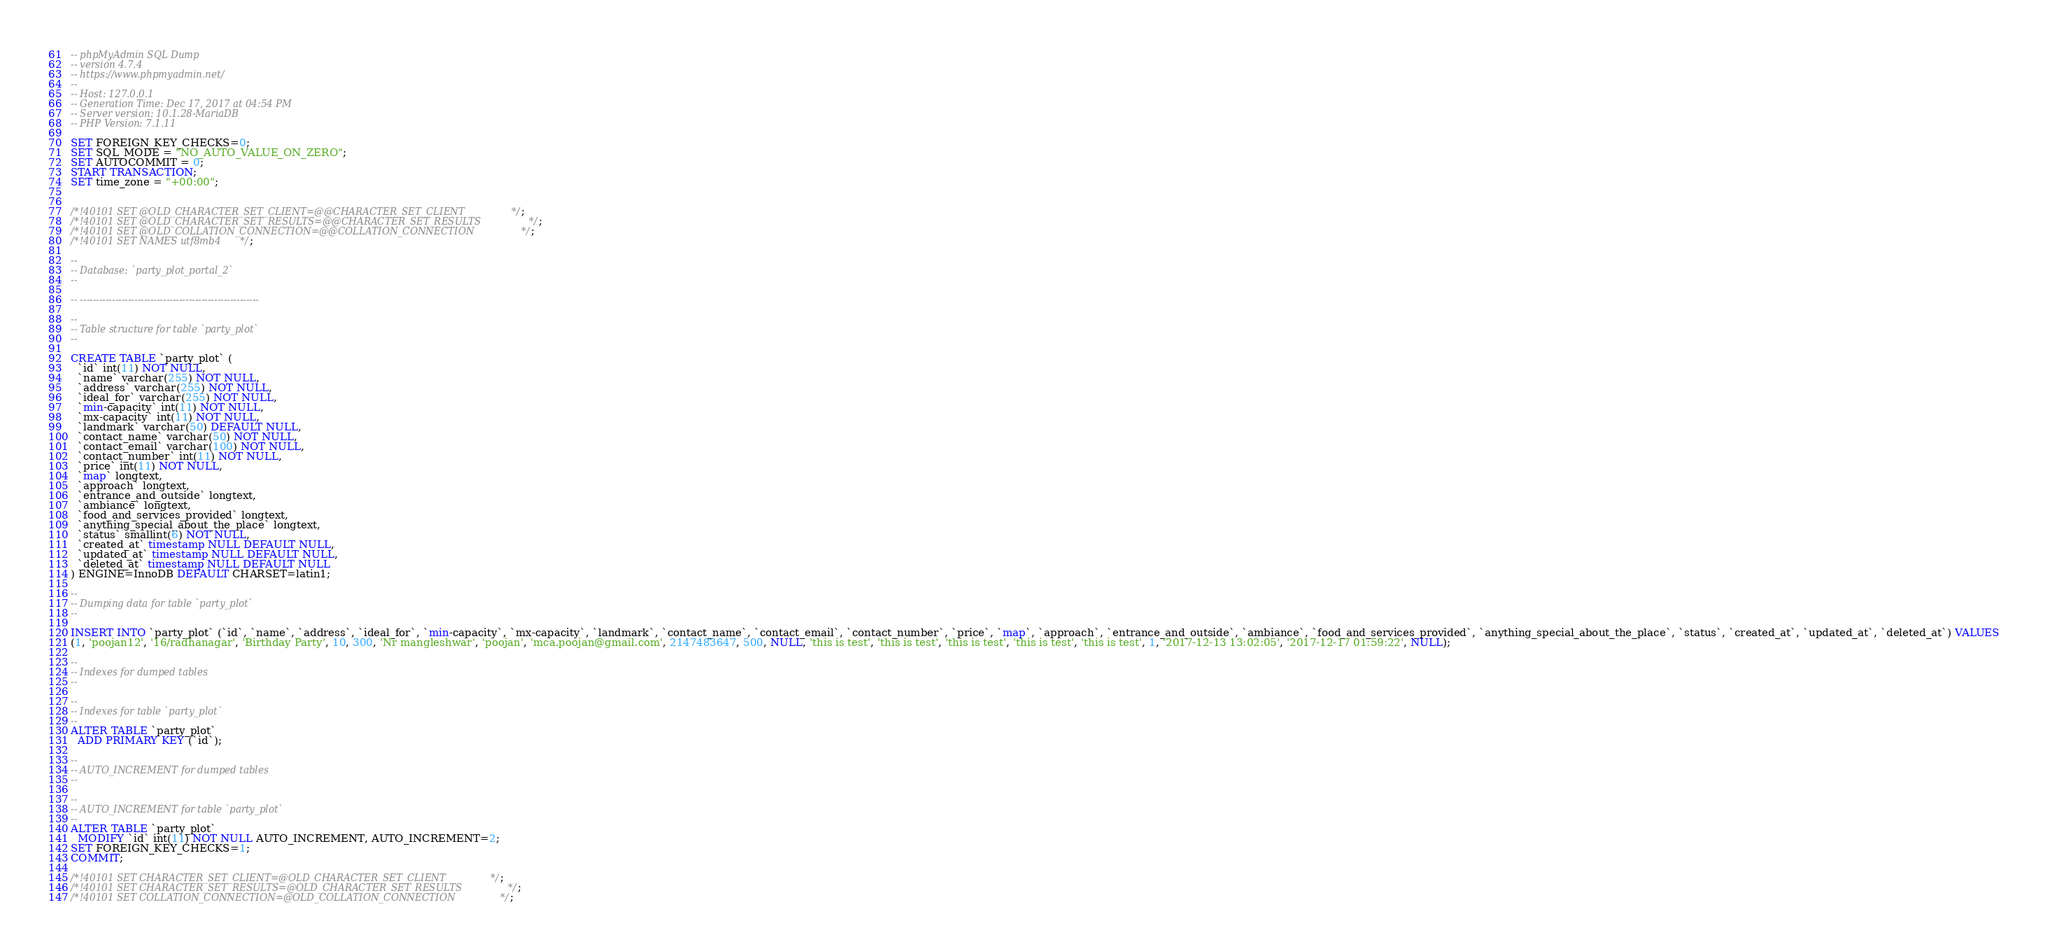<code> <loc_0><loc_0><loc_500><loc_500><_SQL_>-- phpMyAdmin SQL Dump
-- version 4.7.4
-- https://www.phpmyadmin.net/
--
-- Host: 127.0.0.1
-- Generation Time: Dec 17, 2017 at 04:54 PM
-- Server version: 10.1.28-MariaDB
-- PHP Version: 7.1.11

SET FOREIGN_KEY_CHECKS=0;
SET SQL_MODE = "NO_AUTO_VALUE_ON_ZERO";
SET AUTOCOMMIT = 0;
START TRANSACTION;
SET time_zone = "+00:00";


/*!40101 SET @OLD_CHARACTER_SET_CLIENT=@@CHARACTER_SET_CLIENT */;
/*!40101 SET @OLD_CHARACTER_SET_RESULTS=@@CHARACTER_SET_RESULTS */;
/*!40101 SET @OLD_COLLATION_CONNECTION=@@COLLATION_CONNECTION */;
/*!40101 SET NAMES utf8mb4 */;

--
-- Database: `party_plot_portal_2`
--

-- --------------------------------------------------------

--
-- Table structure for table `party_plot`
--

CREATE TABLE `party_plot` (
  `id` int(11) NOT NULL,
  `name` varchar(255) NOT NULL,
  `address` varchar(255) NOT NULL,
  `ideal_for` varchar(255) NOT NULL,
  `min-capacity` int(11) NOT NULL,
  `mx-capacity` int(11) NOT NULL,
  `landmark` varchar(50) DEFAULT NULL,
  `contact_name` varchar(50) NOT NULL,
  `contact_email` varchar(100) NOT NULL,
  `contact_number` int(11) NOT NULL,
  `price` int(11) NOT NULL,
  `map` longtext,
  `approach` longtext,
  `entrance_and_outside` longtext,
  `ambiance` longtext,
  `food_and_services_provided` longtext,
  `anything_special_about_the_place` longtext,
  `status` smallint(6) NOT NULL,
  `created_at` timestamp NULL DEFAULT NULL,
  `updated_at` timestamp NULL DEFAULT NULL,
  `deleted_at` timestamp NULL DEFAULT NULL
) ENGINE=InnoDB DEFAULT CHARSET=latin1;

--
-- Dumping data for table `party_plot`
--

INSERT INTO `party_plot` (`id`, `name`, `address`, `ideal_for`, `min-capacity`, `mx-capacity`, `landmark`, `contact_name`, `contact_email`, `contact_number`, `price`, `map`, `approach`, `entrance_and_outside`, `ambiance`, `food_and_services_provided`, `anything_special_about_the_place`, `status`, `created_at`, `updated_at`, `deleted_at`) VALUES
(1, 'poojan12', '16/radhanagar', 'Birthday Party', 10, 300, 'Nr mangleshwar', 'poojan', 'mca.poojan@gmail.com', 2147483647, 500, NULL, 'this is test', 'this is test', 'this is test', 'this is test', 'this is test', 1, '2017-12-13 13:02:05', '2017-12-17 01:59:22', NULL);

--
-- Indexes for dumped tables
--

--
-- Indexes for table `party_plot`
--
ALTER TABLE `party_plot`
  ADD PRIMARY KEY (`id`);

--
-- AUTO_INCREMENT for dumped tables
--

--
-- AUTO_INCREMENT for table `party_plot`
--
ALTER TABLE `party_plot`
  MODIFY `id` int(11) NOT NULL AUTO_INCREMENT, AUTO_INCREMENT=2;
SET FOREIGN_KEY_CHECKS=1;
COMMIT;

/*!40101 SET CHARACTER_SET_CLIENT=@OLD_CHARACTER_SET_CLIENT */;
/*!40101 SET CHARACTER_SET_RESULTS=@OLD_CHARACTER_SET_RESULTS */;
/*!40101 SET COLLATION_CONNECTION=@OLD_COLLATION_CONNECTION */;
</code> 